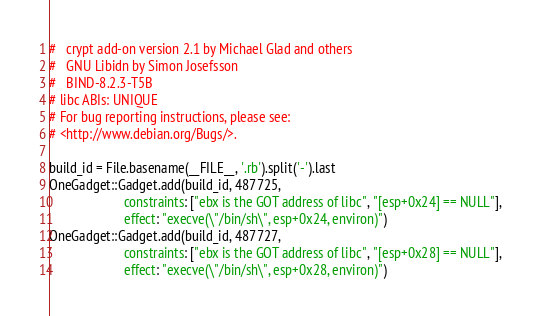<code> <loc_0><loc_0><loc_500><loc_500><_Ruby_># 	crypt add-on version 2.1 by Michael Glad and others
# 	GNU Libidn by Simon Josefsson
# 	BIND-8.2.3-T5B
# libc ABIs: UNIQUE
# For bug reporting instructions, please see:
# <http://www.debian.org/Bugs/>.

build_id = File.basename(__FILE__, '.rb').split('-').last
OneGadget::Gadget.add(build_id, 487725,
                      constraints: ["ebx is the GOT address of libc", "[esp+0x24] == NULL"],
                      effect: "execve(\"/bin/sh\", esp+0x24, environ)")
OneGadget::Gadget.add(build_id, 487727,
                      constraints: ["ebx is the GOT address of libc", "[esp+0x28] == NULL"],
                      effect: "execve(\"/bin/sh\", esp+0x28, environ)")</code> 